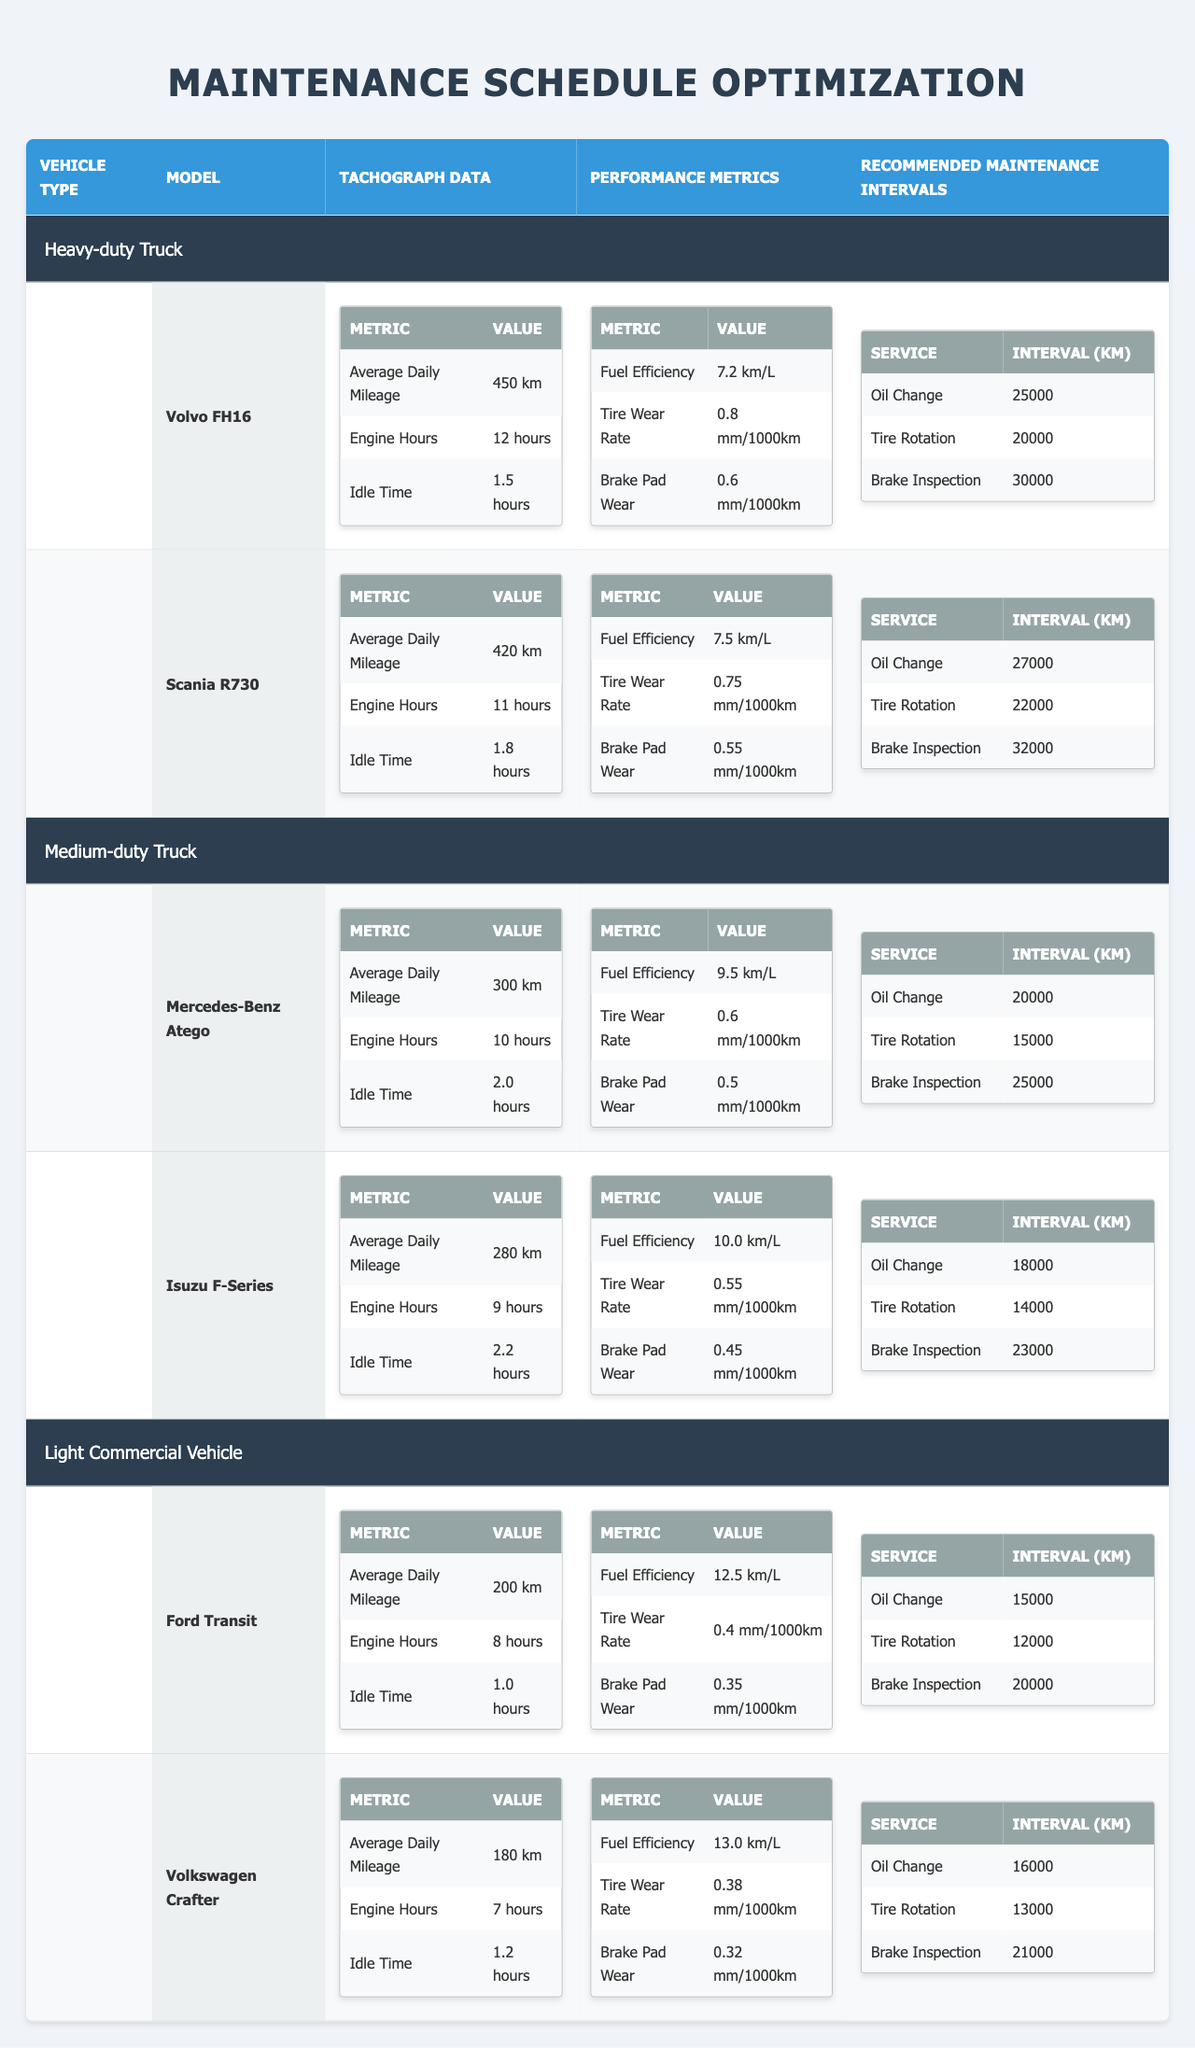What is the average daily mileage of the Volvo FH16? The table specifies the tachograph data for the Volvo FH16, which shows an "Average Daily Mileage" of 450 km.
Answer: 450 km What is the recommended oil change interval for the Isuzu F-Series? Looking at the "Recommended Maintenance Intervals" for the Isuzu F-Series, the "Oil Change" interval is listed as 18,000 km.
Answer: 18,000 km Which vehicle has the highest fuel efficiency according to the table? Analyzing the "Fuel Efficiency" values, the Ford Transit has a value of 12.5 km/L, which is higher than the fuel efficiency of other vehicles in the table.
Answer: Ford Transit What is the total recommended maintenance interval for all models listed under Heavy-duty Truck? To find the total recommended maintenance interval, add the oil change, tire rotation, and brake inspection intervals for each model: Volvo FH16: 25000 + 20000 + 30000 = 75000 km; Scania R730: 27000 + 22000 + 32000 = 81000 km. The total is 75000 + 81000 = 156000 km.
Answer: 156,000 km Is the tire wear rate for the Mercedes-Benz Atego higher or lower than that of the Isuzu F-Series? The tire wear rate for the Mercedes-Benz Atego is 0.6 mm/1000 km, while the Isuzu F-Series has a tire wear rate of 0.55 mm/1000 km. Therefore, the tire wear rate for the Mercedes-Benz Atego is higher.
Answer: Higher What is the difference in idle time between the Scania R730 and the Volvo FH16? The idle time for the Scania R730 is 1.8 hours and for the Volvo FH16 it is 1.5 hours. The difference is calculated as 1.8 - 1.5 = 0.3 hours.
Answer: 0.3 hours Which vehicle type has the most varied range in brake pad wear rates? The table shows three vehicle types: Heavy-duty Truck (0.55 - 0.8 mm/1000 km), Medium-duty Truck (0.45 - 0.6 mm/1000 km), and Light Commercial Vehicle (0.32 - 0.4 mm/1000 km). Heavy-duty Truck has the largest range (0.25 mm), indicating the most variation in brake pad wear rates.
Answer: Heavy-duty Truck What percentage increase in recommended oil change interval is there from the Isuzu F-Series to the Scania R730? The recommended oil change interval for the Isuzu F-Series is 18,000 km and for the Scania R730 it is 27,000 km. The increase is 27000 - 18000 = 9000 km. The percentage increase is calculated as (9000/18000) * 100 = 50%.
Answer: 50% 